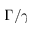Convert formula to latex. <formula><loc_0><loc_0><loc_500><loc_500>\Gamma / \gamma</formula> 